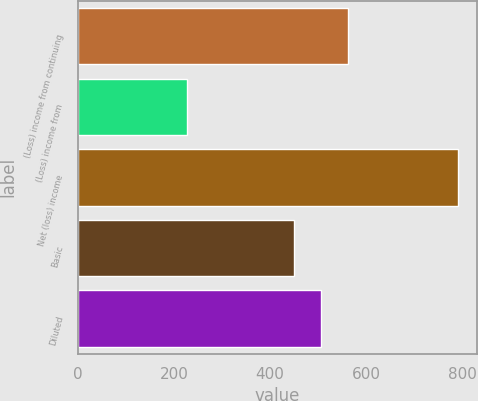Convert chart to OTSL. <chart><loc_0><loc_0><loc_500><loc_500><bar_chart><fcel>(Loss) income from continuing<fcel>(Loss) income from<fcel>Net (loss) income<fcel>Basic<fcel>Diluted<nl><fcel>563<fcel>228<fcel>791<fcel>450<fcel>506.3<nl></chart> 